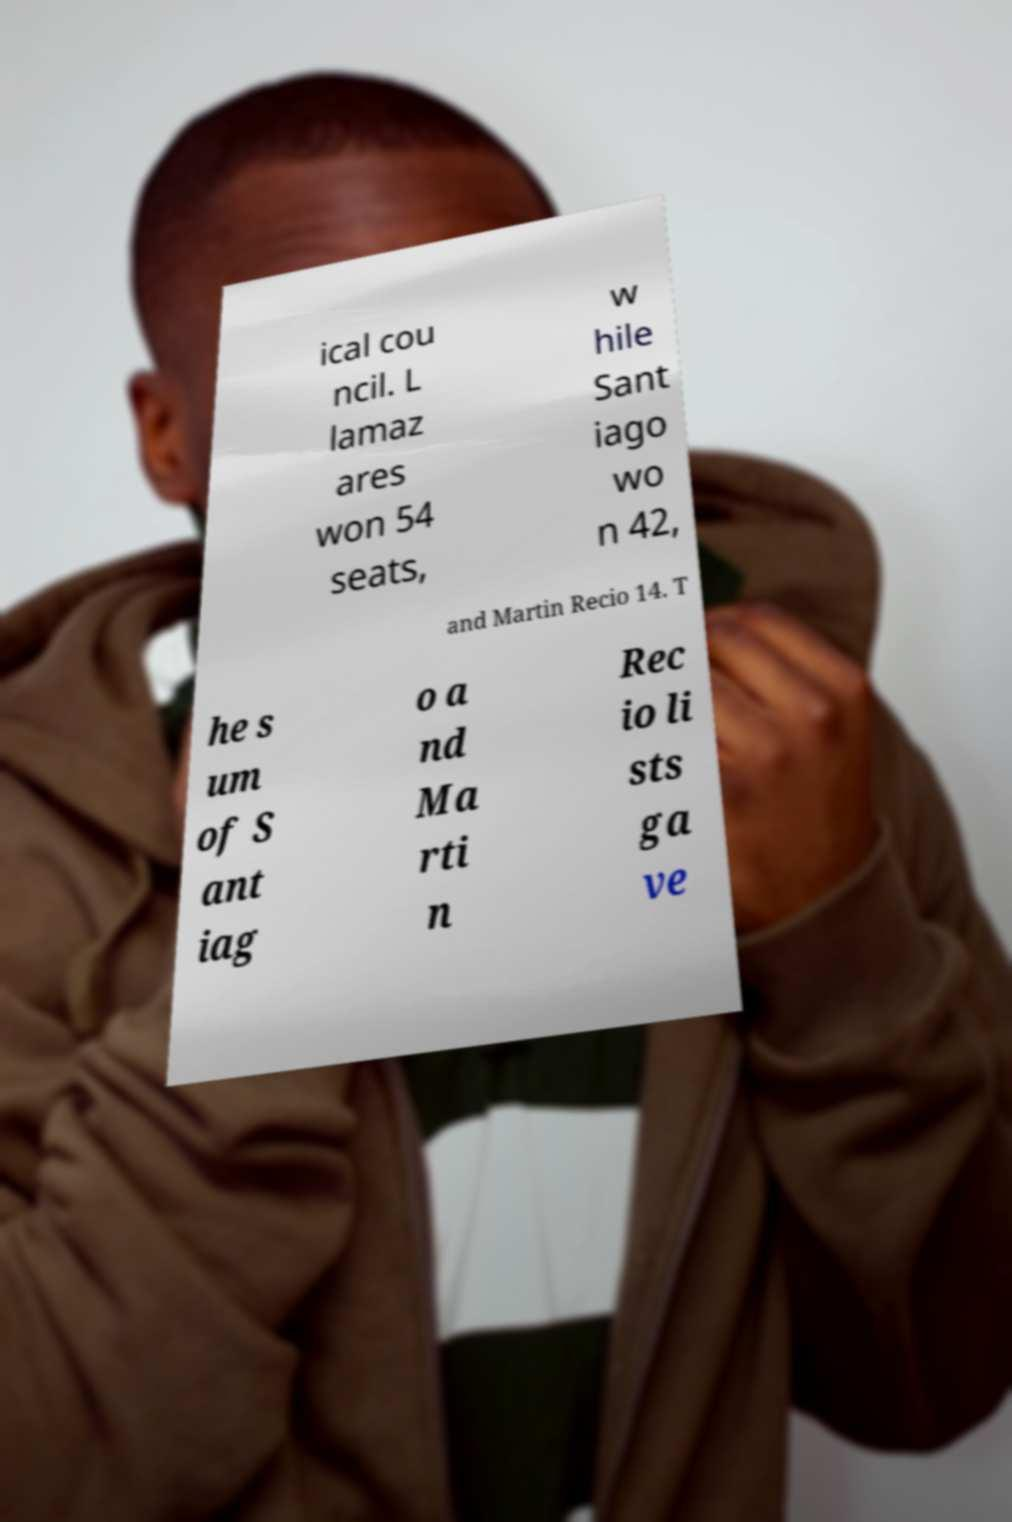What messages or text are displayed in this image? I need them in a readable, typed format. ical cou ncil. L lamaz ares won 54 seats, w hile Sant iago wo n 42, and Martin Recio 14. T he s um of S ant iag o a nd Ma rti n Rec io li sts ga ve 